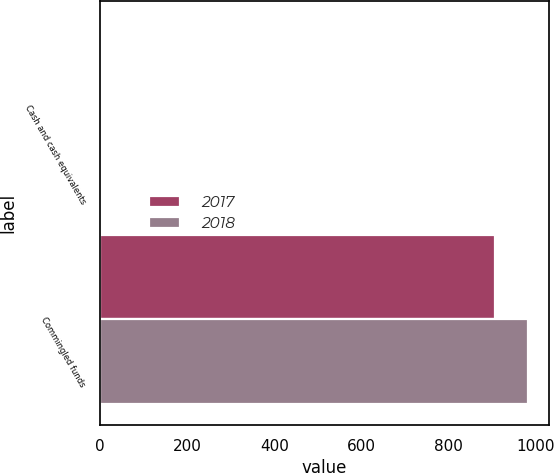Convert chart to OTSL. <chart><loc_0><loc_0><loc_500><loc_500><stacked_bar_chart><ecel><fcel>Cash and cash equivalents<fcel>Commingled funds<nl><fcel>2017<fcel>3<fcel>906<nl><fcel>2018<fcel>3<fcel>982<nl></chart> 